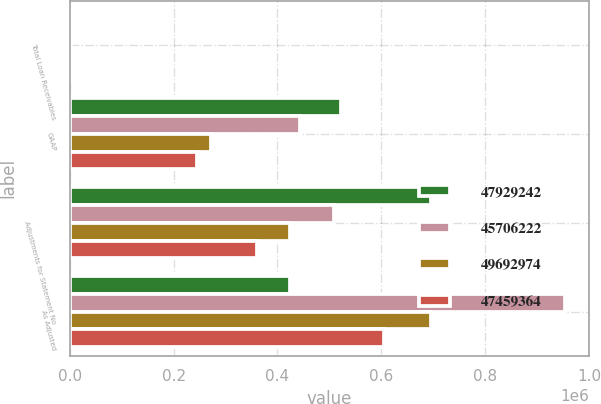Convert chart. <chart><loc_0><loc_0><loc_500><loc_500><stacked_bar_chart><ecel><fcel>Total Loan Receivables<fcel>GAAP<fcel>Adjustments for Statement No<fcel>As Adjusted<nl><fcel>4.79292e+07<fcel>2009<fcel>522190<fcel>694864<fcel>424075<nl><fcel>4.57062e+07<fcel>2008<fcel>444324<fcel>508241<fcel>952565<nl><fcel>4.9693e+07<fcel>2007<fcel>271227<fcel>424075<fcel>695302<nl><fcel>4.74594e+07<fcel>2006<fcel>244675<fcel>360118<fcel>604793<nl></chart> 